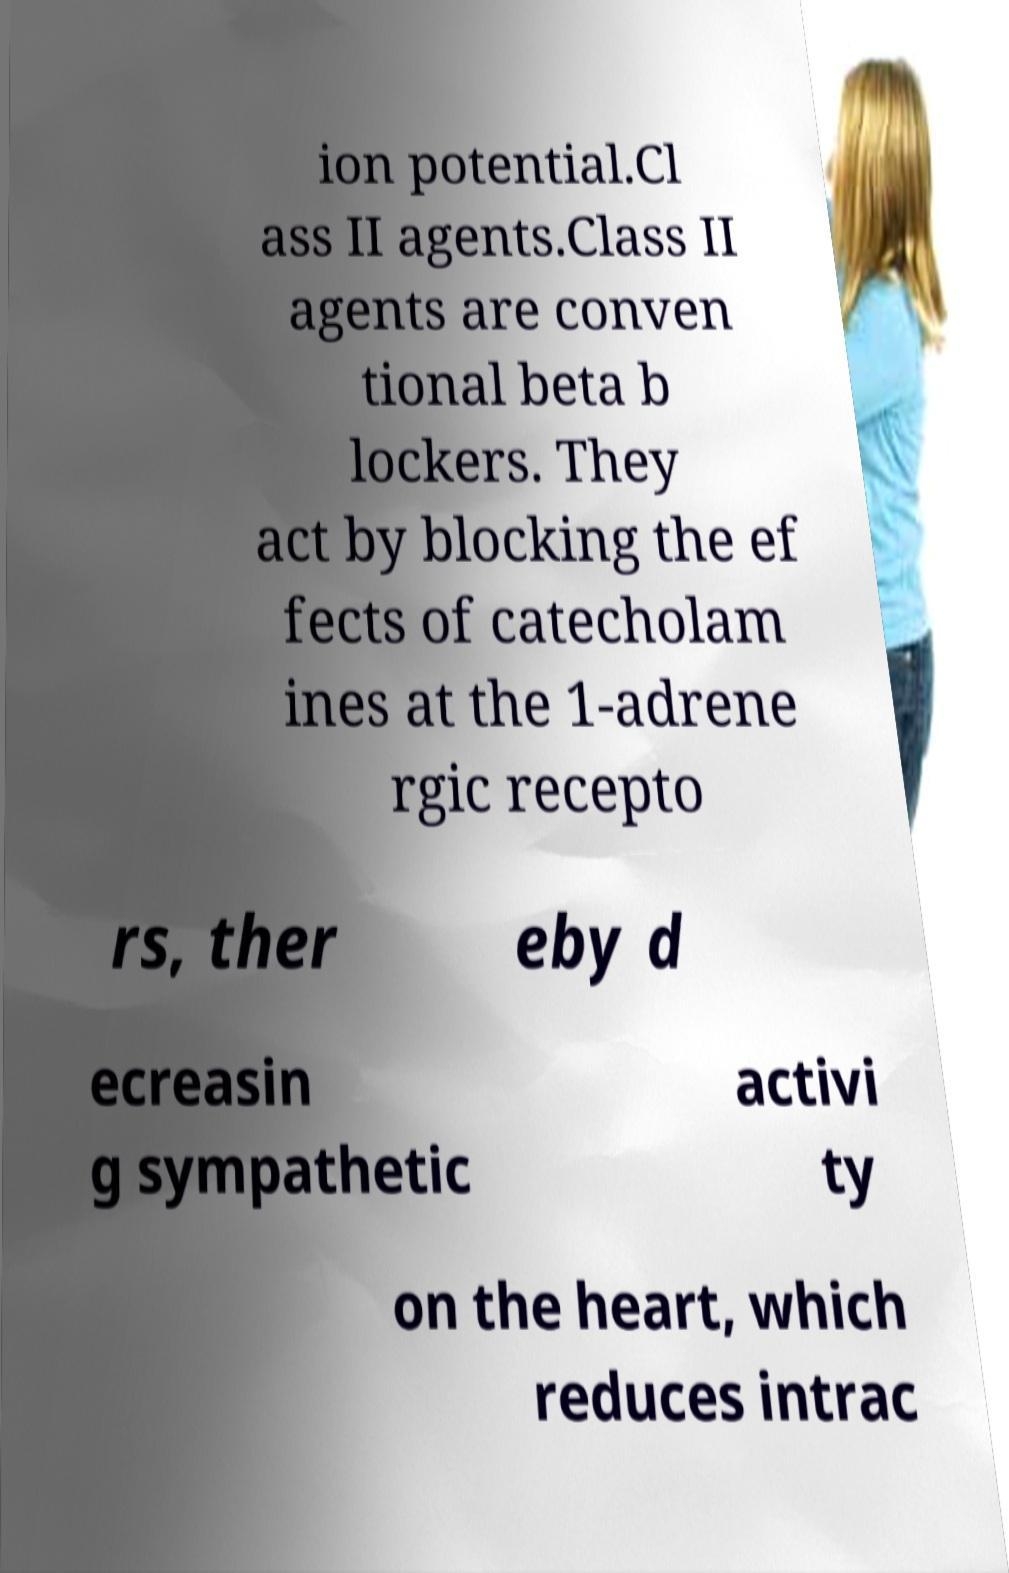Please read and relay the text visible in this image. What does it say? ion potential.Cl ass II agents.Class II agents are conven tional beta b lockers. They act by blocking the ef fects of catecholam ines at the 1-adrene rgic recepto rs, ther eby d ecreasin g sympathetic activi ty on the heart, which reduces intrac 